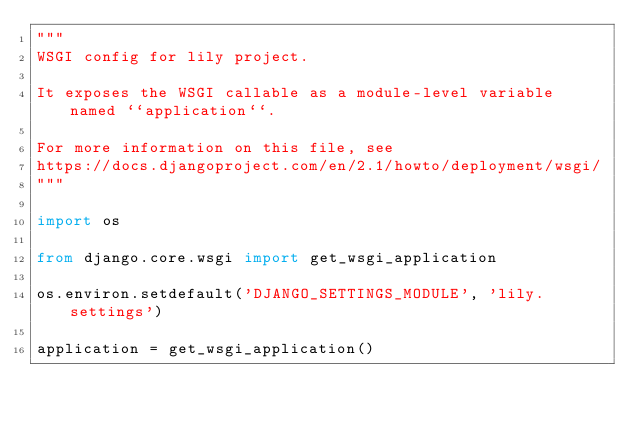<code> <loc_0><loc_0><loc_500><loc_500><_Python_>"""
WSGI config for lily project.

It exposes the WSGI callable as a module-level variable named ``application``.

For more information on this file, see
https://docs.djangoproject.com/en/2.1/howto/deployment/wsgi/
"""

import os

from django.core.wsgi import get_wsgi_application

os.environ.setdefault('DJANGO_SETTINGS_MODULE', 'lily.settings')

application = get_wsgi_application()
</code> 